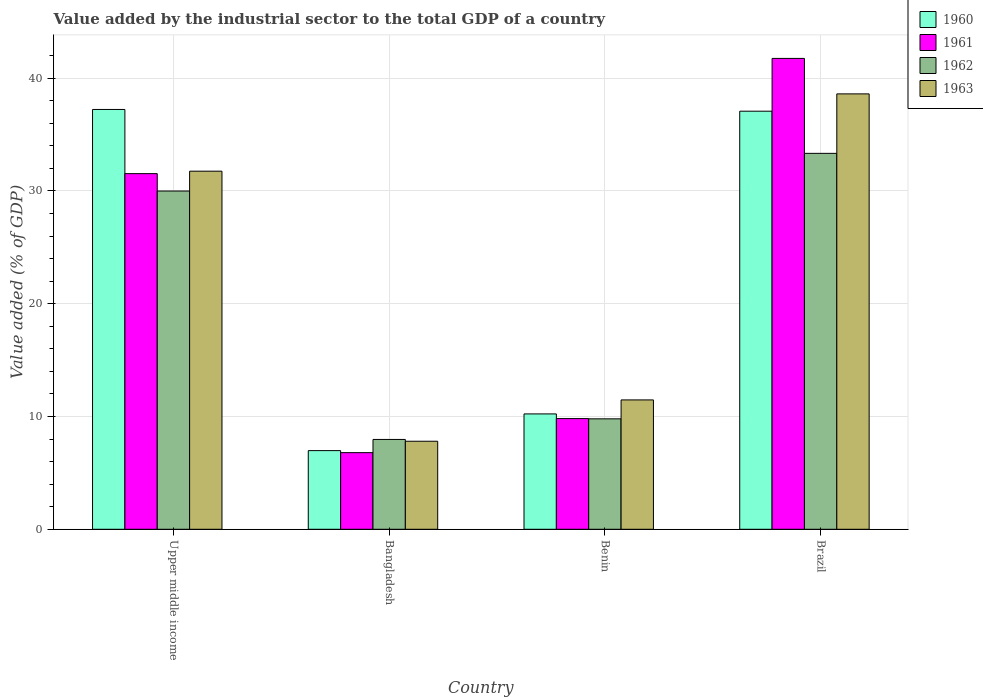How many different coloured bars are there?
Offer a terse response. 4. Are the number of bars per tick equal to the number of legend labels?
Keep it short and to the point. Yes. Are the number of bars on each tick of the X-axis equal?
Give a very brief answer. Yes. How many bars are there on the 1st tick from the left?
Your response must be concise. 4. How many bars are there on the 1st tick from the right?
Ensure brevity in your answer.  4. What is the label of the 3rd group of bars from the left?
Give a very brief answer. Benin. What is the value added by the industrial sector to the total GDP in 1961 in Bangladesh?
Provide a succinct answer. 6.79. Across all countries, what is the maximum value added by the industrial sector to the total GDP in 1960?
Offer a terse response. 37.22. Across all countries, what is the minimum value added by the industrial sector to the total GDP in 1960?
Your answer should be compact. 6.97. In which country was the value added by the industrial sector to the total GDP in 1962 maximum?
Make the answer very short. Brazil. In which country was the value added by the industrial sector to the total GDP in 1963 minimum?
Offer a very short reply. Bangladesh. What is the total value added by the industrial sector to the total GDP in 1962 in the graph?
Keep it short and to the point. 81.07. What is the difference between the value added by the industrial sector to the total GDP in 1961 in Benin and that in Upper middle income?
Provide a succinct answer. -21.72. What is the difference between the value added by the industrial sector to the total GDP in 1963 in Bangladesh and the value added by the industrial sector to the total GDP in 1962 in Upper middle income?
Keep it short and to the point. -22.18. What is the average value added by the industrial sector to the total GDP in 1960 per country?
Ensure brevity in your answer.  22.87. What is the difference between the value added by the industrial sector to the total GDP of/in 1961 and value added by the industrial sector to the total GDP of/in 1960 in Upper middle income?
Provide a succinct answer. -5.69. What is the ratio of the value added by the industrial sector to the total GDP in 1963 in Benin to that in Upper middle income?
Provide a short and direct response. 0.36. Is the value added by the industrial sector to the total GDP in 1963 in Brazil less than that in Upper middle income?
Provide a succinct answer. No. What is the difference between the highest and the second highest value added by the industrial sector to the total GDP in 1961?
Your answer should be compact. 31.93. What is the difference between the highest and the lowest value added by the industrial sector to the total GDP in 1961?
Give a very brief answer. 34.95. Is the sum of the value added by the industrial sector to the total GDP in 1963 in Bangladesh and Benin greater than the maximum value added by the industrial sector to the total GDP in 1960 across all countries?
Provide a succinct answer. No. How many bars are there?
Ensure brevity in your answer.  16. How many countries are there in the graph?
Provide a short and direct response. 4. Does the graph contain any zero values?
Ensure brevity in your answer.  No. Where does the legend appear in the graph?
Your answer should be compact. Top right. How are the legend labels stacked?
Keep it short and to the point. Vertical. What is the title of the graph?
Ensure brevity in your answer.  Value added by the industrial sector to the total GDP of a country. Does "2006" appear as one of the legend labels in the graph?
Keep it short and to the point. No. What is the label or title of the Y-axis?
Your response must be concise. Value added (% of GDP). What is the Value added (% of GDP) in 1960 in Upper middle income?
Your answer should be very brief. 37.22. What is the Value added (% of GDP) of 1961 in Upper middle income?
Make the answer very short. 31.53. What is the Value added (% of GDP) of 1962 in Upper middle income?
Offer a very short reply. 29.99. What is the Value added (% of GDP) in 1963 in Upper middle income?
Keep it short and to the point. 31.75. What is the Value added (% of GDP) of 1960 in Bangladesh?
Make the answer very short. 6.97. What is the Value added (% of GDP) of 1961 in Bangladesh?
Your answer should be very brief. 6.79. What is the Value added (% of GDP) in 1962 in Bangladesh?
Make the answer very short. 7.96. What is the Value added (% of GDP) of 1963 in Bangladesh?
Keep it short and to the point. 7.8. What is the Value added (% of GDP) in 1960 in Benin?
Provide a short and direct response. 10.23. What is the Value added (% of GDP) of 1961 in Benin?
Offer a very short reply. 9.81. What is the Value added (% of GDP) of 1962 in Benin?
Keep it short and to the point. 9.79. What is the Value added (% of GDP) of 1963 in Benin?
Your answer should be very brief. 11.47. What is the Value added (% of GDP) of 1960 in Brazil?
Offer a very short reply. 37.07. What is the Value added (% of GDP) of 1961 in Brazil?
Keep it short and to the point. 41.75. What is the Value added (% of GDP) of 1962 in Brazil?
Ensure brevity in your answer.  33.33. What is the Value added (% of GDP) of 1963 in Brazil?
Your answer should be very brief. 38.6. Across all countries, what is the maximum Value added (% of GDP) of 1960?
Give a very brief answer. 37.22. Across all countries, what is the maximum Value added (% of GDP) in 1961?
Keep it short and to the point. 41.75. Across all countries, what is the maximum Value added (% of GDP) in 1962?
Ensure brevity in your answer.  33.33. Across all countries, what is the maximum Value added (% of GDP) in 1963?
Make the answer very short. 38.6. Across all countries, what is the minimum Value added (% of GDP) of 1960?
Offer a very short reply. 6.97. Across all countries, what is the minimum Value added (% of GDP) in 1961?
Your response must be concise. 6.79. Across all countries, what is the minimum Value added (% of GDP) in 1962?
Make the answer very short. 7.96. Across all countries, what is the minimum Value added (% of GDP) in 1963?
Your answer should be very brief. 7.8. What is the total Value added (% of GDP) of 1960 in the graph?
Keep it short and to the point. 91.49. What is the total Value added (% of GDP) in 1961 in the graph?
Keep it short and to the point. 89.88. What is the total Value added (% of GDP) in 1962 in the graph?
Your answer should be compact. 81.07. What is the total Value added (% of GDP) in 1963 in the graph?
Offer a very short reply. 89.62. What is the difference between the Value added (% of GDP) in 1960 in Upper middle income and that in Bangladesh?
Your answer should be compact. 30.25. What is the difference between the Value added (% of GDP) in 1961 in Upper middle income and that in Bangladesh?
Offer a very short reply. 24.74. What is the difference between the Value added (% of GDP) in 1962 in Upper middle income and that in Bangladesh?
Offer a very short reply. 22.02. What is the difference between the Value added (% of GDP) in 1963 in Upper middle income and that in Bangladesh?
Offer a very short reply. 23.94. What is the difference between the Value added (% of GDP) in 1960 in Upper middle income and that in Benin?
Ensure brevity in your answer.  26.99. What is the difference between the Value added (% of GDP) of 1961 in Upper middle income and that in Benin?
Provide a short and direct response. 21.72. What is the difference between the Value added (% of GDP) of 1962 in Upper middle income and that in Benin?
Provide a succinct answer. 20.2. What is the difference between the Value added (% of GDP) in 1963 in Upper middle income and that in Benin?
Provide a short and direct response. 20.28. What is the difference between the Value added (% of GDP) of 1960 in Upper middle income and that in Brazil?
Your answer should be compact. 0.15. What is the difference between the Value added (% of GDP) of 1961 in Upper middle income and that in Brazil?
Your answer should be compact. -10.21. What is the difference between the Value added (% of GDP) of 1962 in Upper middle income and that in Brazil?
Make the answer very short. -3.34. What is the difference between the Value added (% of GDP) of 1963 in Upper middle income and that in Brazil?
Provide a succinct answer. -6.85. What is the difference between the Value added (% of GDP) of 1960 in Bangladesh and that in Benin?
Keep it short and to the point. -3.25. What is the difference between the Value added (% of GDP) of 1961 in Bangladesh and that in Benin?
Provide a short and direct response. -3.02. What is the difference between the Value added (% of GDP) in 1962 in Bangladesh and that in Benin?
Your answer should be very brief. -1.83. What is the difference between the Value added (% of GDP) of 1963 in Bangladesh and that in Benin?
Your answer should be very brief. -3.66. What is the difference between the Value added (% of GDP) of 1960 in Bangladesh and that in Brazil?
Make the answer very short. -30.09. What is the difference between the Value added (% of GDP) in 1961 in Bangladesh and that in Brazil?
Keep it short and to the point. -34.95. What is the difference between the Value added (% of GDP) of 1962 in Bangladesh and that in Brazil?
Offer a terse response. -25.37. What is the difference between the Value added (% of GDP) in 1963 in Bangladesh and that in Brazil?
Make the answer very short. -30.8. What is the difference between the Value added (% of GDP) in 1960 in Benin and that in Brazil?
Give a very brief answer. -26.84. What is the difference between the Value added (% of GDP) of 1961 in Benin and that in Brazil?
Offer a very short reply. -31.93. What is the difference between the Value added (% of GDP) of 1962 in Benin and that in Brazil?
Keep it short and to the point. -23.54. What is the difference between the Value added (% of GDP) in 1963 in Benin and that in Brazil?
Your answer should be compact. -27.13. What is the difference between the Value added (% of GDP) of 1960 in Upper middle income and the Value added (% of GDP) of 1961 in Bangladesh?
Offer a terse response. 30.43. What is the difference between the Value added (% of GDP) in 1960 in Upper middle income and the Value added (% of GDP) in 1962 in Bangladesh?
Ensure brevity in your answer.  29.26. What is the difference between the Value added (% of GDP) of 1960 in Upper middle income and the Value added (% of GDP) of 1963 in Bangladesh?
Make the answer very short. 29.42. What is the difference between the Value added (% of GDP) in 1961 in Upper middle income and the Value added (% of GDP) in 1962 in Bangladesh?
Your answer should be very brief. 23.57. What is the difference between the Value added (% of GDP) in 1961 in Upper middle income and the Value added (% of GDP) in 1963 in Bangladesh?
Provide a succinct answer. 23.73. What is the difference between the Value added (% of GDP) of 1962 in Upper middle income and the Value added (% of GDP) of 1963 in Bangladesh?
Offer a terse response. 22.18. What is the difference between the Value added (% of GDP) in 1960 in Upper middle income and the Value added (% of GDP) in 1961 in Benin?
Keep it short and to the point. 27.41. What is the difference between the Value added (% of GDP) of 1960 in Upper middle income and the Value added (% of GDP) of 1962 in Benin?
Your answer should be very brief. 27.43. What is the difference between the Value added (% of GDP) of 1960 in Upper middle income and the Value added (% of GDP) of 1963 in Benin?
Your answer should be very brief. 25.75. What is the difference between the Value added (% of GDP) in 1961 in Upper middle income and the Value added (% of GDP) in 1962 in Benin?
Give a very brief answer. 21.74. What is the difference between the Value added (% of GDP) of 1961 in Upper middle income and the Value added (% of GDP) of 1963 in Benin?
Keep it short and to the point. 20.06. What is the difference between the Value added (% of GDP) in 1962 in Upper middle income and the Value added (% of GDP) in 1963 in Benin?
Your response must be concise. 18.52. What is the difference between the Value added (% of GDP) in 1960 in Upper middle income and the Value added (% of GDP) in 1961 in Brazil?
Offer a very short reply. -4.53. What is the difference between the Value added (% of GDP) in 1960 in Upper middle income and the Value added (% of GDP) in 1962 in Brazil?
Give a very brief answer. 3.89. What is the difference between the Value added (% of GDP) of 1960 in Upper middle income and the Value added (% of GDP) of 1963 in Brazil?
Provide a short and direct response. -1.38. What is the difference between the Value added (% of GDP) in 1961 in Upper middle income and the Value added (% of GDP) in 1962 in Brazil?
Your answer should be very brief. -1.8. What is the difference between the Value added (% of GDP) of 1961 in Upper middle income and the Value added (% of GDP) of 1963 in Brazil?
Your answer should be compact. -7.07. What is the difference between the Value added (% of GDP) of 1962 in Upper middle income and the Value added (% of GDP) of 1963 in Brazil?
Give a very brief answer. -8.61. What is the difference between the Value added (% of GDP) of 1960 in Bangladesh and the Value added (% of GDP) of 1961 in Benin?
Give a very brief answer. -2.84. What is the difference between the Value added (% of GDP) of 1960 in Bangladesh and the Value added (% of GDP) of 1962 in Benin?
Provide a short and direct response. -2.82. What is the difference between the Value added (% of GDP) in 1960 in Bangladesh and the Value added (% of GDP) in 1963 in Benin?
Provide a succinct answer. -4.5. What is the difference between the Value added (% of GDP) in 1961 in Bangladesh and the Value added (% of GDP) in 1962 in Benin?
Make the answer very short. -3. What is the difference between the Value added (% of GDP) in 1961 in Bangladesh and the Value added (% of GDP) in 1963 in Benin?
Provide a succinct answer. -4.68. What is the difference between the Value added (% of GDP) of 1962 in Bangladesh and the Value added (% of GDP) of 1963 in Benin?
Ensure brevity in your answer.  -3.51. What is the difference between the Value added (% of GDP) of 1960 in Bangladesh and the Value added (% of GDP) of 1961 in Brazil?
Provide a short and direct response. -34.77. What is the difference between the Value added (% of GDP) of 1960 in Bangladesh and the Value added (% of GDP) of 1962 in Brazil?
Your answer should be very brief. -26.36. What is the difference between the Value added (% of GDP) of 1960 in Bangladesh and the Value added (% of GDP) of 1963 in Brazil?
Your answer should be very brief. -31.63. What is the difference between the Value added (% of GDP) of 1961 in Bangladesh and the Value added (% of GDP) of 1962 in Brazil?
Give a very brief answer. -26.53. What is the difference between the Value added (% of GDP) in 1961 in Bangladesh and the Value added (% of GDP) in 1963 in Brazil?
Offer a very short reply. -31.81. What is the difference between the Value added (% of GDP) of 1962 in Bangladesh and the Value added (% of GDP) of 1963 in Brazil?
Your answer should be compact. -30.64. What is the difference between the Value added (% of GDP) in 1960 in Benin and the Value added (% of GDP) in 1961 in Brazil?
Make the answer very short. -31.52. What is the difference between the Value added (% of GDP) in 1960 in Benin and the Value added (% of GDP) in 1962 in Brazil?
Give a very brief answer. -23.1. What is the difference between the Value added (% of GDP) in 1960 in Benin and the Value added (% of GDP) in 1963 in Brazil?
Keep it short and to the point. -28.37. What is the difference between the Value added (% of GDP) in 1961 in Benin and the Value added (% of GDP) in 1962 in Brazil?
Your response must be concise. -23.52. What is the difference between the Value added (% of GDP) of 1961 in Benin and the Value added (% of GDP) of 1963 in Brazil?
Make the answer very short. -28.79. What is the difference between the Value added (% of GDP) in 1962 in Benin and the Value added (% of GDP) in 1963 in Brazil?
Make the answer very short. -28.81. What is the average Value added (% of GDP) of 1960 per country?
Offer a very short reply. 22.87. What is the average Value added (% of GDP) in 1961 per country?
Your response must be concise. 22.47. What is the average Value added (% of GDP) in 1962 per country?
Offer a very short reply. 20.27. What is the average Value added (% of GDP) of 1963 per country?
Your answer should be compact. 22.41. What is the difference between the Value added (% of GDP) in 1960 and Value added (% of GDP) in 1961 in Upper middle income?
Make the answer very short. 5.69. What is the difference between the Value added (% of GDP) in 1960 and Value added (% of GDP) in 1962 in Upper middle income?
Offer a very short reply. 7.23. What is the difference between the Value added (% of GDP) in 1960 and Value added (% of GDP) in 1963 in Upper middle income?
Ensure brevity in your answer.  5.47. What is the difference between the Value added (% of GDP) of 1961 and Value added (% of GDP) of 1962 in Upper middle income?
Give a very brief answer. 1.54. What is the difference between the Value added (% of GDP) in 1961 and Value added (% of GDP) in 1963 in Upper middle income?
Provide a succinct answer. -0.22. What is the difference between the Value added (% of GDP) in 1962 and Value added (% of GDP) in 1963 in Upper middle income?
Provide a succinct answer. -1.76. What is the difference between the Value added (% of GDP) of 1960 and Value added (% of GDP) of 1961 in Bangladesh?
Make the answer very short. 0.18. What is the difference between the Value added (% of GDP) of 1960 and Value added (% of GDP) of 1962 in Bangladesh?
Give a very brief answer. -0.99. What is the difference between the Value added (% of GDP) in 1960 and Value added (% of GDP) in 1963 in Bangladesh?
Give a very brief answer. -0.83. What is the difference between the Value added (% of GDP) in 1961 and Value added (% of GDP) in 1962 in Bangladesh?
Give a very brief answer. -1.17. What is the difference between the Value added (% of GDP) of 1961 and Value added (% of GDP) of 1963 in Bangladesh?
Your answer should be compact. -1.01. What is the difference between the Value added (% of GDP) in 1962 and Value added (% of GDP) in 1963 in Bangladesh?
Your answer should be compact. 0.16. What is the difference between the Value added (% of GDP) in 1960 and Value added (% of GDP) in 1961 in Benin?
Your answer should be compact. 0.41. What is the difference between the Value added (% of GDP) in 1960 and Value added (% of GDP) in 1962 in Benin?
Keep it short and to the point. 0.44. What is the difference between the Value added (% of GDP) in 1960 and Value added (% of GDP) in 1963 in Benin?
Give a very brief answer. -1.24. What is the difference between the Value added (% of GDP) of 1961 and Value added (% of GDP) of 1962 in Benin?
Your answer should be very brief. 0.02. What is the difference between the Value added (% of GDP) of 1961 and Value added (% of GDP) of 1963 in Benin?
Provide a succinct answer. -1.66. What is the difference between the Value added (% of GDP) in 1962 and Value added (% of GDP) in 1963 in Benin?
Offer a terse response. -1.68. What is the difference between the Value added (% of GDP) of 1960 and Value added (% of GDP) of 1961 in Brazil?
Provide a short and direct response. -4.68. What is the difference between the Value added (% of GDP) of 1960 and Value added (% of GDP) of 1962 in Brazil?
Provide a short and direct response. 3.74. What is the difference between the Value added (% of GDP) in 1960 and Value added (% of GDP) in 1963 in Brazil?
Your answer should be compact. -1.53. What is the difference between the Value added (% of GDP) of 1961 and Value added (% of GDP) of 1962 in Brazil?
Ensure brevity in your answer.  8.42. What is the difference between the Value added (% of GDP) in 1961 and Value added (% of GDP) in 1963 in Brazil?
Ensure brevity in your answer.  3.14. What is the difference between the Value added (% of GDP) of 1962 and Value added (% of GDP) of 1963 in Brazil?
Make the answer very short. -5.27. What is the ratio of the Value added (% of GDP) in 1960 in Upper middle income to that in Bangladesh?
Provide a short and direct response. 5.34. What is the ratio of the Value added (% of GDP) of 1961 in Upper middle income to that in Bangladesh?
Your answer should be very brief. 4.64. What is the ratio of the Value added (% of GDP) in 1962 in Upper middle income to that in Bangladesh?
Keep it short and to the point. 3.77. What is the ratio of the Value added (% of GDP) in 1963 in Upper middle income to that in Bangladesh?
Provide a short and direct response. 4.07. What is the ratio of the Value added (% of GDP) of 1960 in Upper middle income to that in Benin?
Offer a terse response. 3.64. What is the ratio of the Value added (% of GDP) of 1961 in Upper middle income to that in Benin?
Offer a very short reply. 3.21. What is the ratio of the Value added (% of GDP) of 1962 in Upper middle income to that in Benin?
Keep it short and to the point. 3.06. What is the ratio of the Value added (% of GDP) of 1963 in Upper middle income to that in Benin?
Keep it short and to the point. 2.77. What is the ratio of the Value added (% of GDP) of 1961 in Upper middle income to that in Brazil?
Your response must be concise. 0.76. What is the ratio of the Value added (% of GDP) of 1962 in Upper middle income to that in Brazil?
Provide a succinct answer. 0.9. What is the ratio of the Value added (% of GDP) of 1963 in Upper middle income to that in Brazil?
Your response must be concise. 0.82. What is the ratio of the Value added (% of GDP) in 1960 in Bangladesh to that in Benin?
Give a very brief answer. 0.68. What is the ratio of the Value added (% of GDP) in 1961 in Bangladesh to that in Benin?
Provide a succinct answer. 0.69. What is the ratio of the Value added (% of GDP) in 1962 in Bangladesh to that in Benin?
Offer a terse response. 0.81. What is the ratio of the Value added (% of GDP) in 1963 in Bangladesh to that in Benin?
Make the answer very short. 0.68. What is the ratio of the Value added (% of GDP) in 1960 in Bangladesh to that in Brazil?
Make the answer very short. 0.19. What is the ratio of the Value added (% of GDP) of 1961 in Bangladesh to that in Brazil?
Offer a terse response. 0.16. What is the ratio of the Value added (% of GDP) in 1962 in Bangladesh to that in Brazil?
Provide a succinct answer. 0.24. What is the ratio of the Value added (% of GDP) in 1963 in Bangladesh to that in Brazil?
Your answer should be very brief. 0.2. What is the ratio of the Value added (% of GDP) of 1960 in Benin to that in Brazil?
Your answer should be very brief. 0.28. What is the ratio of the Value added (% of GDP) of 1961 in Benin to that in Brazil?
Keep it short and to the point. 0.24. What is the ratio of the Value added (% of GDP) in 1962 in Benin to that in Brazil?
Make the answer very short. 0.29. What is the ratio of the Value added (% of GDP) of 1963 in Benin to that in Brazil?
Your answer should be very brief. 0.3. What is the difference between the highest and the second highest Value added (% of GDP) in 1960?
Give a very brief answer. 0.15. What is the difference between the highest and the second highest Value added (% of GDP) in 1961?
Your response must be concise. 10.21. What is the difference between the highest and the second highest Value added (% of GDP) in 1962?
Provide a succinct answer. 3.34. What is the difference between the highest and the second highest Value added (% of GDP) of 1963?
Keep it short and to the point. 6.85. What is the difference between the highest and the lowest Value added (% of GDP) in 1960?
Provide a succinct answer. 30.25. What is the difference between the highest and the lowest Value added (% of GDP) in 1961?
Keep it short and to the point. 34.95. What is the difference between the highest and the lowest Value added (% of GDP) in 1962?
Your response must be concise. 25.37. What is the difference between the highest and the lowest Value added (% of GDP) in 1963?
Give a very brief answer. 30.8. 